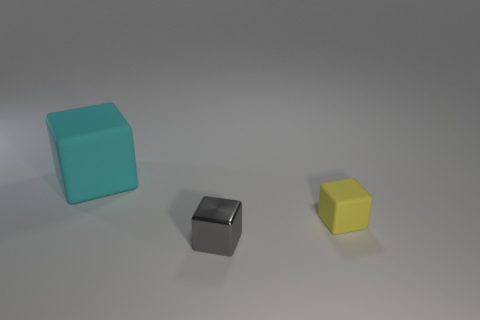Does the tiny thing that is behind the gray metal cube have the same material as the small gray block?
Your response must be concise. No. Are there any cyan matte blocks that have the same size as the yellow block?
Give a very brief answer. No. There is a gray thing; does it have the same shape as the matte thing to the right of the cyan cube?
Your answer should be very brief. Yes. There is a matte block that is to the left of the object that is on the right side of the gray metal block; are there any gray shiny things that are left of it?
Make the answer very short. No. How big is the gray cube?
Offer a very short reply. Small. Does the small thing to the left of the small yellow thing have the same shape as the cyan thing?
Provide a short and direct response. Yes. What is the color of the other matte thing that is the same shape as the big cyan matte object?
Your answer should be very brief. Yellow. Is there anything else that is the same material as the large object?
Give a very brief answer. Yes. What is the size of the other gray shiny object that is the same shape as the big object?
Provide a short and direct response. Small. There is a object that is both in front of the large object and behind the shiny thing; what is it made of?
Provide a succinct answer. Rubber. 